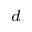<formula> <loc_0><loc_0><loc_500><loc_500>^ { d }</formula> 